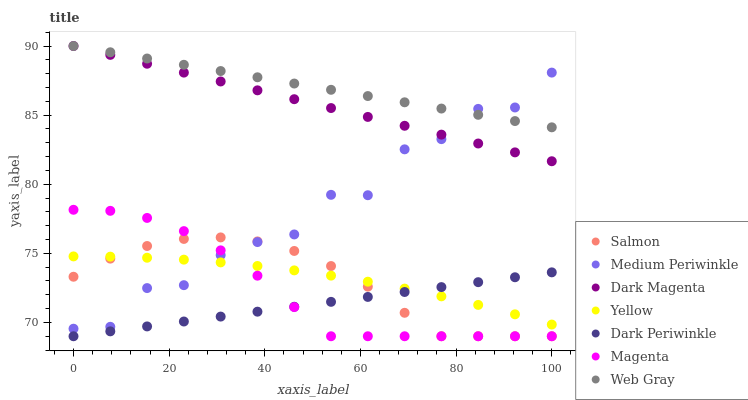Does Dark Periwinkle have the minimum area under the curve?
Answer yes or no. Yes. Does Web Gray have the maximum area under the curve?
Answer yes or no. Yes. Does Dark Magenta have the minimum area under the curve?
Answer yes or no. No. Does Dark Magenta have the maximum area under the curve?
Answer yes or no. No. Is Web Gray the smoothest?
Answer yes or no. Yes. Is Medium Periwinkle the roughest?
Answer yes or no. Yes. Is Dark Magenta the smoothest?
Answer yes or no. No. Is Dark Magenta the roughest?
Answer yes or no. No. Does Salmon have the lowest value?
Answer yes or no. Yes. Does Dark Magenta have the lowest value?
Answer yes or no. No. Does Dark Magenta have the highest value?
Answer yes or no. Yes. Does Salmon have the highest value?
Answer yes or no. No. Is Dark Periwinkle less than Web Gray?
Answer yes or no. Yes. Is Dark Magenta greater than Yellow?
Answer yes or no. Yes. Does Yellow intersect Salmon?
Answer yes or no. Yes. Is Yellow less than Salmon?
Answer yes or no. No. Is Yellow greater than Salmon?
Answer yes or no. No. Does Dark Periwinkle intersect Web Gray?
Answer yes or no. No. 